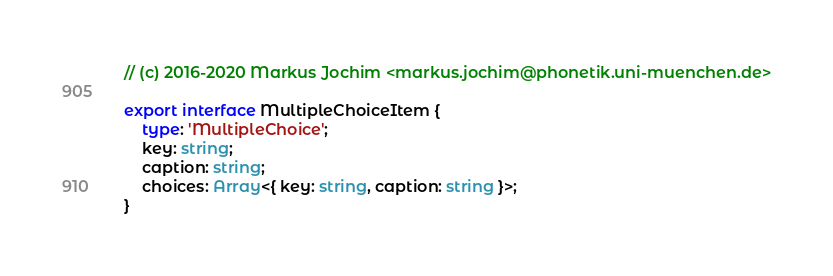<code> <loc_0><loc_0><loc_500><loc_500><_TypeScript_>// (c) 2016-2020 Markus Jochim <markus.jochim@phonetik.uni-muenchen.de>

export interface MultipleChoiceItem {
	type: 'MultipleChoice';
	key: string;
	caption: string;
	choices: Array<{ key: string, caption: string }>;
}
</code> 